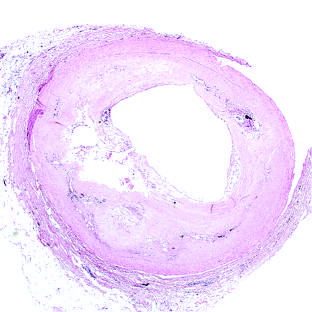what is in a patient who died suddenly?
Answer the question using a single word or phrase. Plaque rupture without superimposed thrombus 